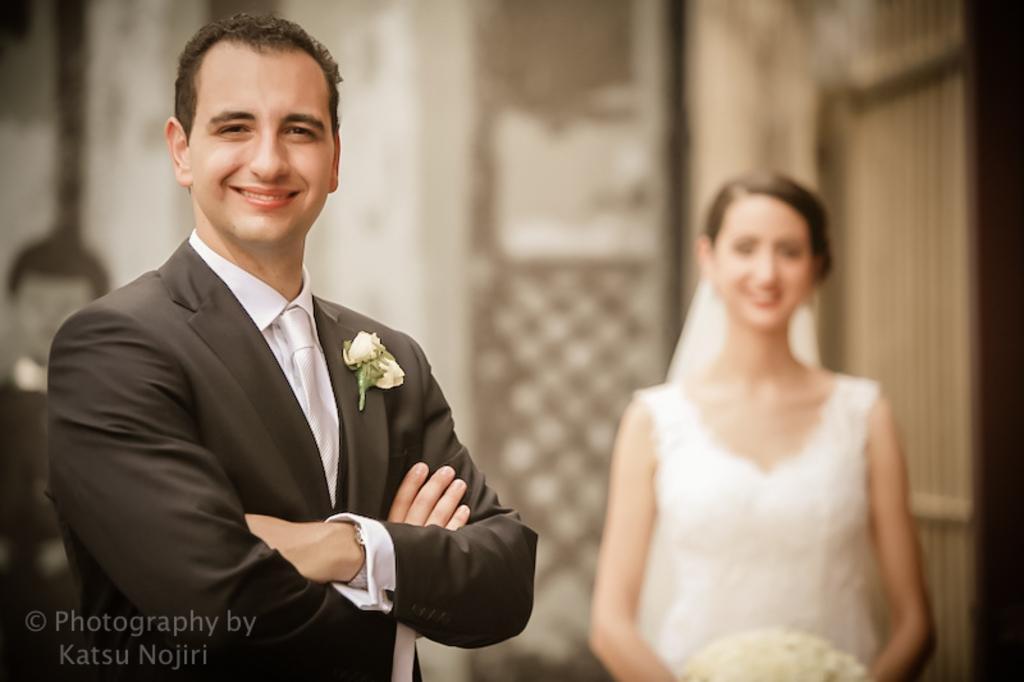How would you summarize this image in a sentence or two? In this image we can see a man and a woman standing. In that a woman is holding a bouquet. On the backside we can see a wall. 